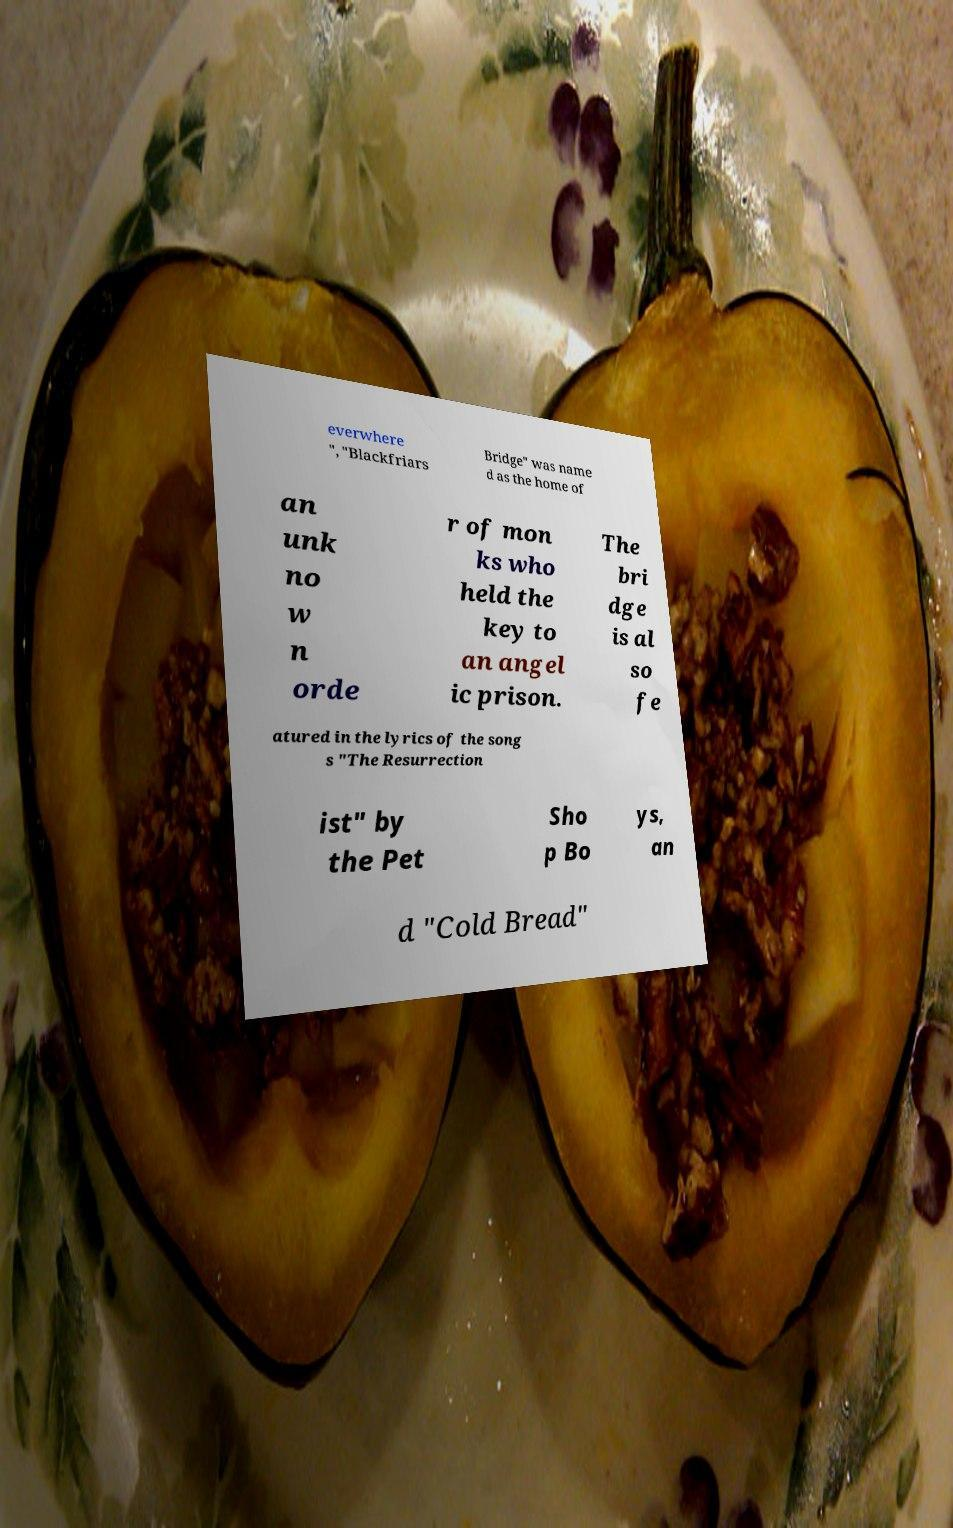Could you extract and type out the text from this image? everwhere ", "Blackfriars Bridge" was name d as the home of an unk no w n orde r of mon ks who held the key to an angel ic prison. The bri dge is al so fe atured in the lyrics of the song s "The Resurrection ist" by the Pet Sho p Bo ys, an d "Cold Bread" 